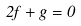Convert formula to latex. <formula><loc_0><loc_0><loc_500><loc_500>2 f + g = 0</formula> 